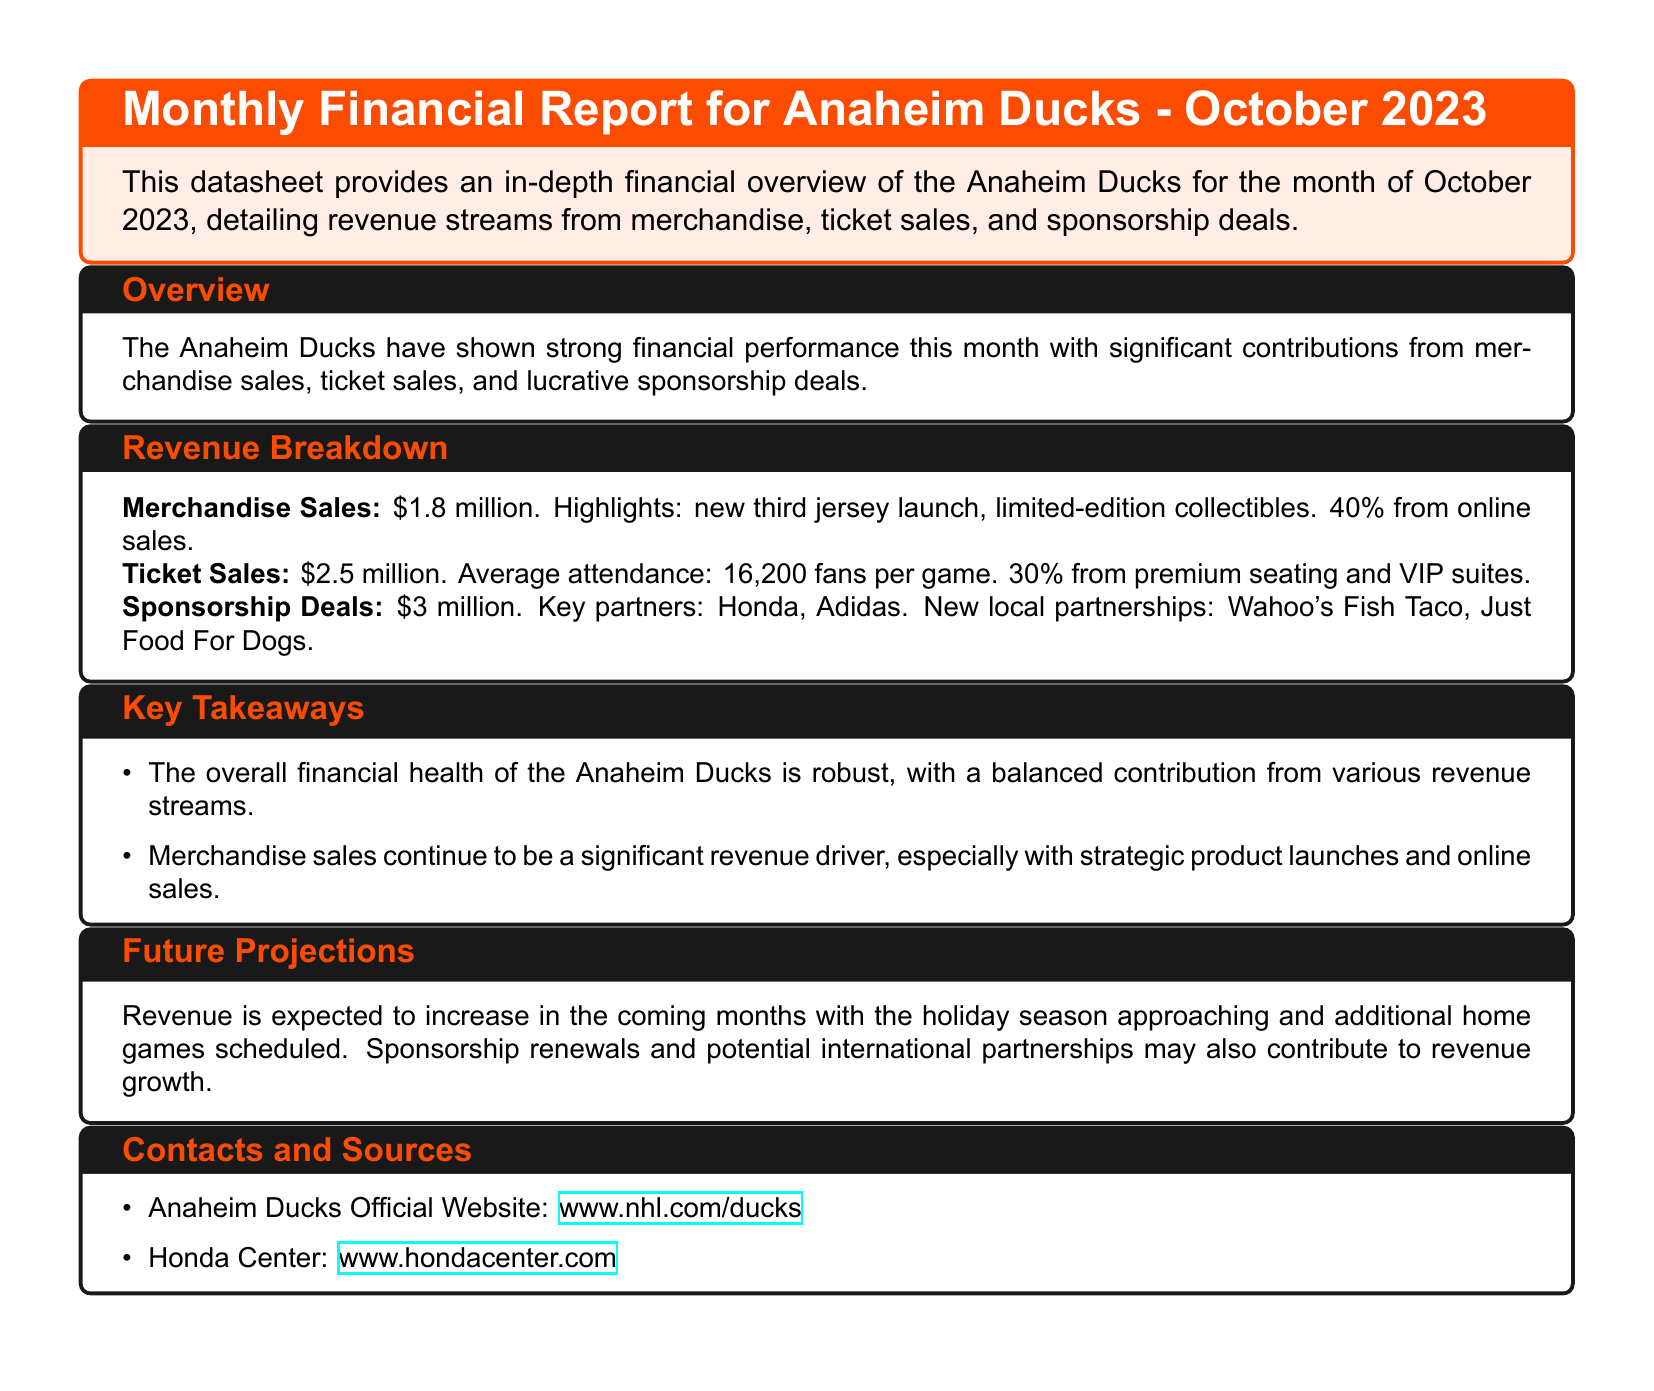what was the merchandise sales revenue for October 2023? The revenue from merchandise sales for October 2023 is specifically mentioned in the document.
Answer: $1.8 million what was the ticket sales revenue for October 2023? The ticket sales revenue is clearly outlined in the revenue breakdown section of the document.
Answer: $2.5 million who are the key partners in sponsorship deals? Key partners are explicitly mentioned in the sponsorship deals section, summarizing significant contributors.
Answer: Honda, Adidas what percentage of merchandise sales came from online sales? The document specifies the percentage of merchandise sales attributed to online sales in the revenue breakdown.
Answer: 40% what was the average attendance per game in October 2023? The average attendance figure is provided in the ticket sales revenue section of the report.
Answer: 16,200 fans which new local partners are mentioned in the sponsorship deals? The document notes new local partnerships in the sponsorship deals section, signifying additional financial contributors.
Answer: Wahoo's Fish Taco, Just Food For Dogs what contributions are expected to increase revenue in future months? The document discusses anticipated contributions to revenue growth in the future projections section, outlining various factors.
Answer: Holiday season, additional home games what is the overall financial health of the Anaheim Ducks as of October 2023? The document evaluates the overall financial health in the key takeaways section, summarizing the financial performance clearly.
Answer: Robust what type of merchandise sales are highlighted as significant? The document emphasizes specific types of merchandise sales in the revenue breakdown, indicating key revenue sources.
Answer: New third jersey launch, limited-edition collectibles 